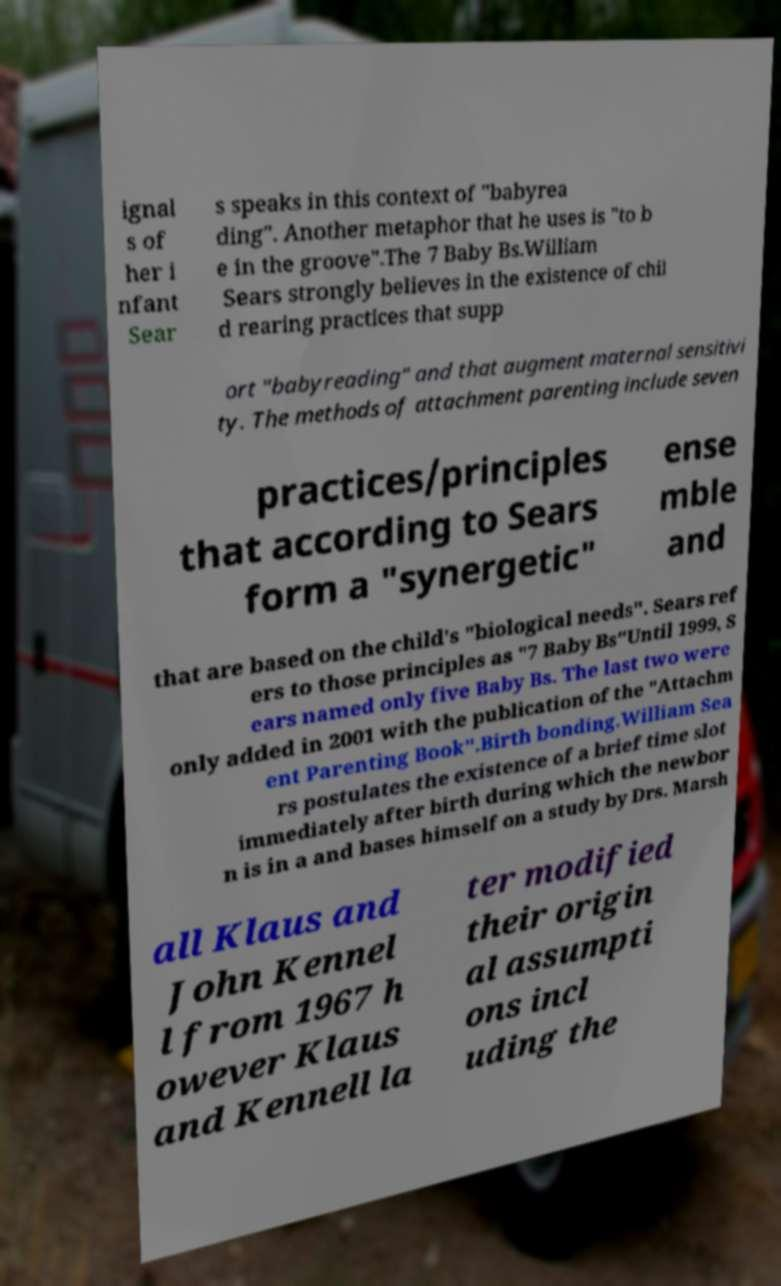There's text embedded in this image that I need extracted. Can you transcribe it verbatim? ignal s of her i nfant Sear s speaks in this context of "babyrea ding". Another metaphor that he uses is "to b e in the groove".The 7 Baby Bs.William Sears strongly believes in the existence of chil d rearing practices that supp ort "babyreading" and that augment maternal sensitivi ty. The methods of attachment parenting include seven practices/principles that according to Sears form a "synergetic" ense mble and that are based on the child's "biological needs". Sears ref ers to those principles as "7 Baby Bs"Until 1999, S ears named only five Baby Bs. The last two were only added in 2001 with the publication of the "Attachm ent Parenting Book".Birth bonding.William Sea rs postulates the existence of a brief time slot immediately after birth during which the newbor n is in a and bases himself on a study by Drs. Marsh all Klaus and John Kennel l from 1967 h owever Klaus and Kennell la ter modified their origin al assumpti ons incl uding the 